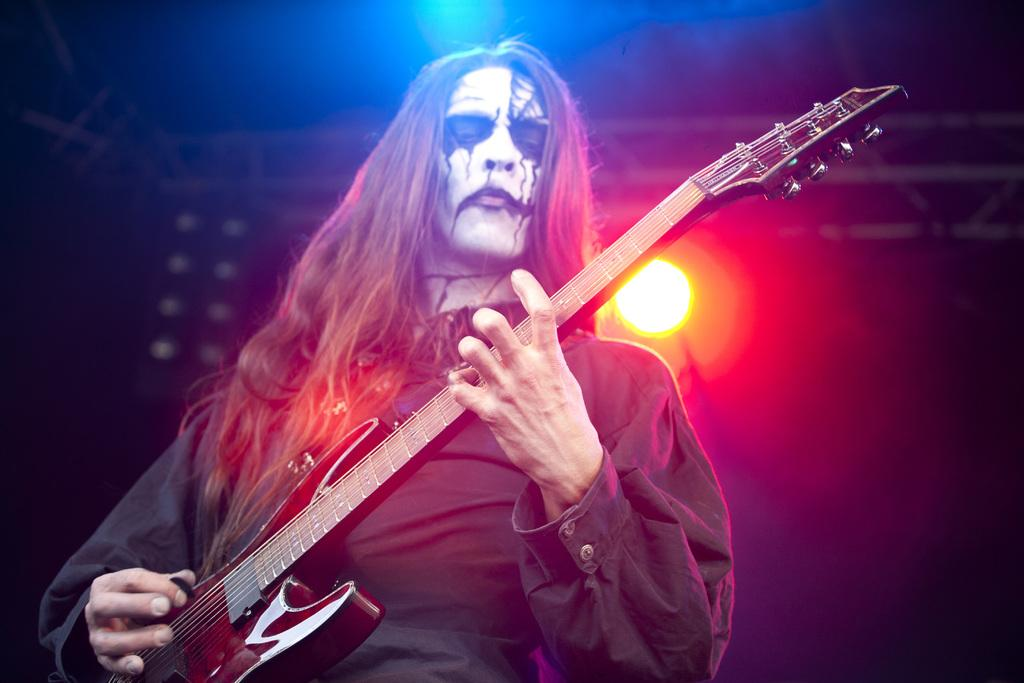What is the person in the image doing? The person is playing a guitar. What can be seen in the background of the image? There is a light in the background of the image. What is the person wearing? The person is wearing a black jacket. What color is the guitar? The guitar is brown in color. What type of bead is being used to stir the person's coffee in the image? There is no coffee or bead present in the image. 